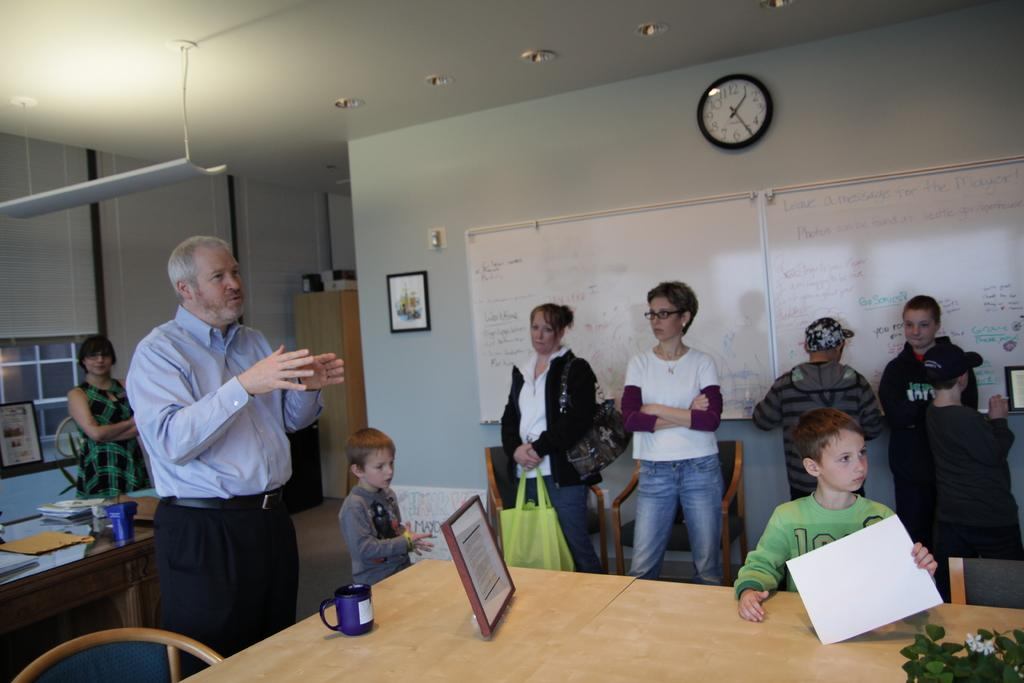How many persons are visible in the image? There are persons standing in the image. What object is present in the image that typically holds photographs or artwork? There is a frame in the image. What object is present in the image that is commonly used for drinking? There is a glass in the image. What is placed on a table in the image? There is a tree on a table in the image. What objects can be seen in the background of the image? There is a board and a clock in the background of the image. What is present on a wall in the background of the image? There is a frame on a wall in the background of the image. Can you tell me how many persons are making a request in the image? There is no information about persons making requests in the image. What type of burn is visible on the tree in the image? There is no burn visible on the tree in the image; it is a tree on a table. 